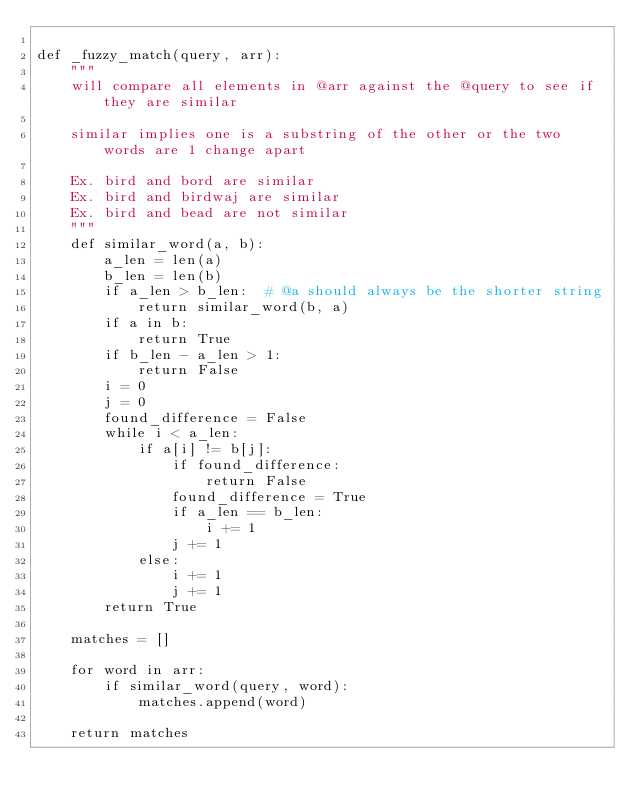<code> <loc_0><loc_0><loc_500><loc_500><_Python_>
def _fuzzy_match(query, arr):
    """
    will compare all elements in @arr against the @query to see if they are similar

    similar implies one is a substring of the other or the two words are 1 change apart

    Ex. bird and bord are similar
    Ex. bird and birdwaj are similar
    Ex. bird and bead are not similar
    """
    def similar_word(a, b):
        a_len = len(a)
        b_len = len(b)
        if a_len > b_len:  # @a should always be the shorter string
            return similar_word(b, a)
        if a in b:
            return True
        if b_len - a_len > 1:
            return False
        i = 0
        j = 0
        found_difference = False
        while i < a_len:
            if a[i] != b[j]:
                if found_difference:
                    return False
                found_difference = True
                if a_len == b_len:
                    i += 1
                j += 1
            else:
                i += 1
                j += 1
        return True

    matches = []

    for word in arr:
        if similar_word(query, word):
            matches.append(word)

    return matches
</code> 